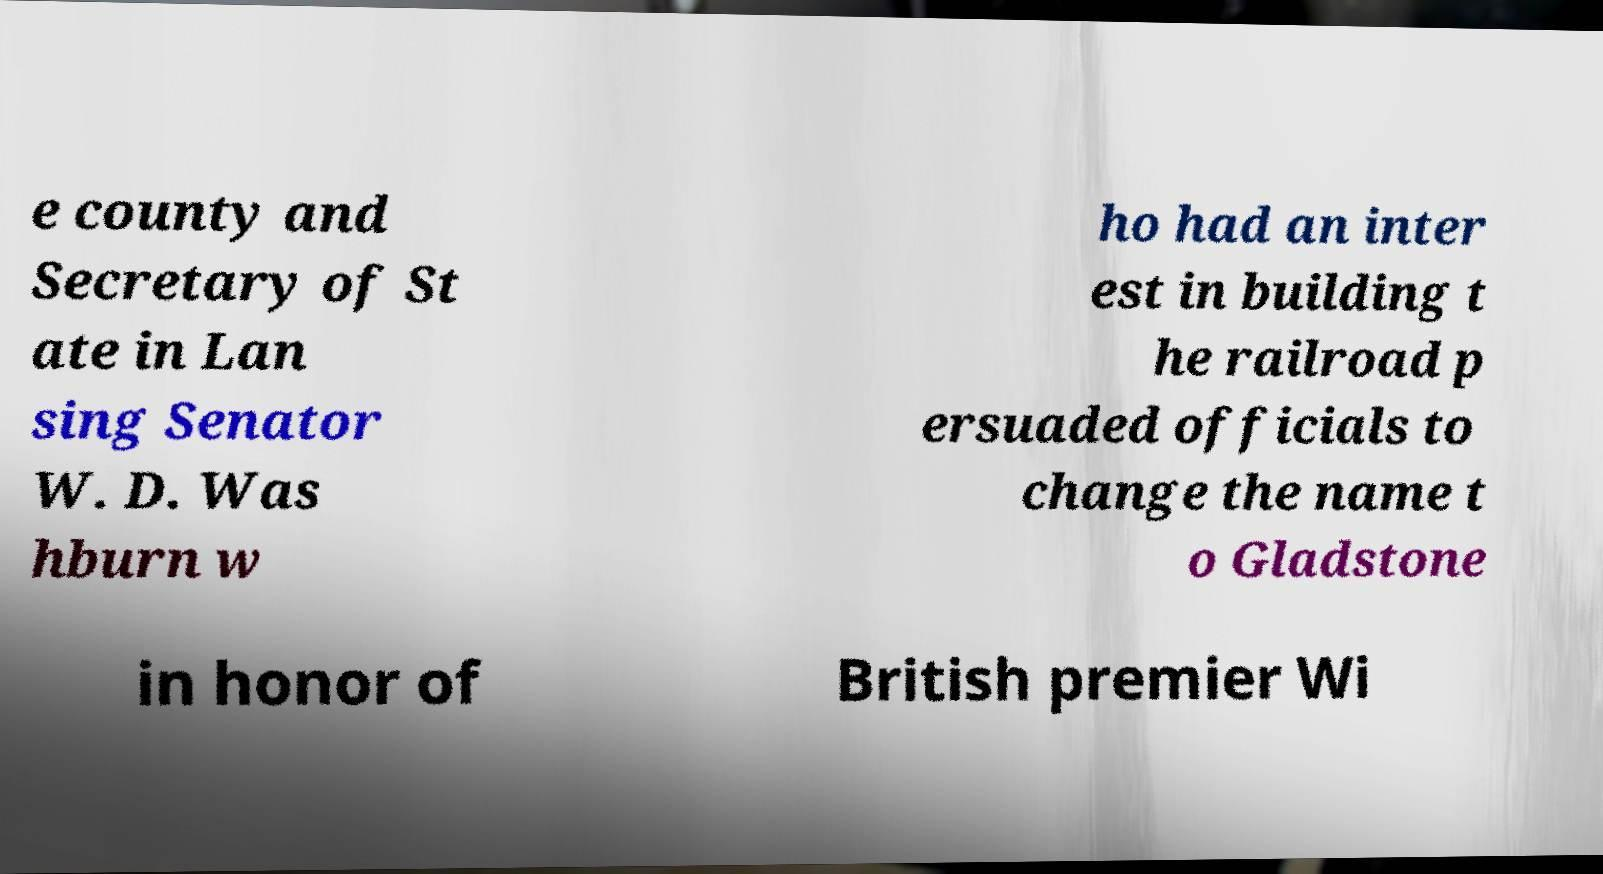I need the written content from this picture converted into text. Can you do that? e county and Secretary of St ate in Lan sing Senator W. D. Was hburn w ho had an inter est in building t he railroad p ersuaded officials to change the name t o Gladstone in honor of British premier Wi 